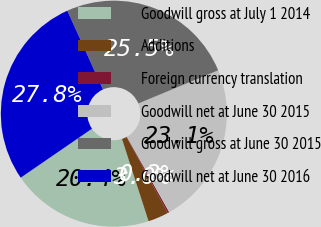<chart> <loc_0><loc_0><loc_500><loc_500><pie_chart><fcel>Goodwill gross at July 1 2014<fcel>Additions<fcel>Foreign currency translation<fcel>Goodwill net at June 30 2015<fcel>Goodwill gross at June 30 2015<fcel>Goodwill net at June 30 2016<nl><fcel>20.39%<fcel>2.95%<fcel>0.23%<fcel>23.12%<fcel>25.48%<fcel>27.83%<nl></chart> 